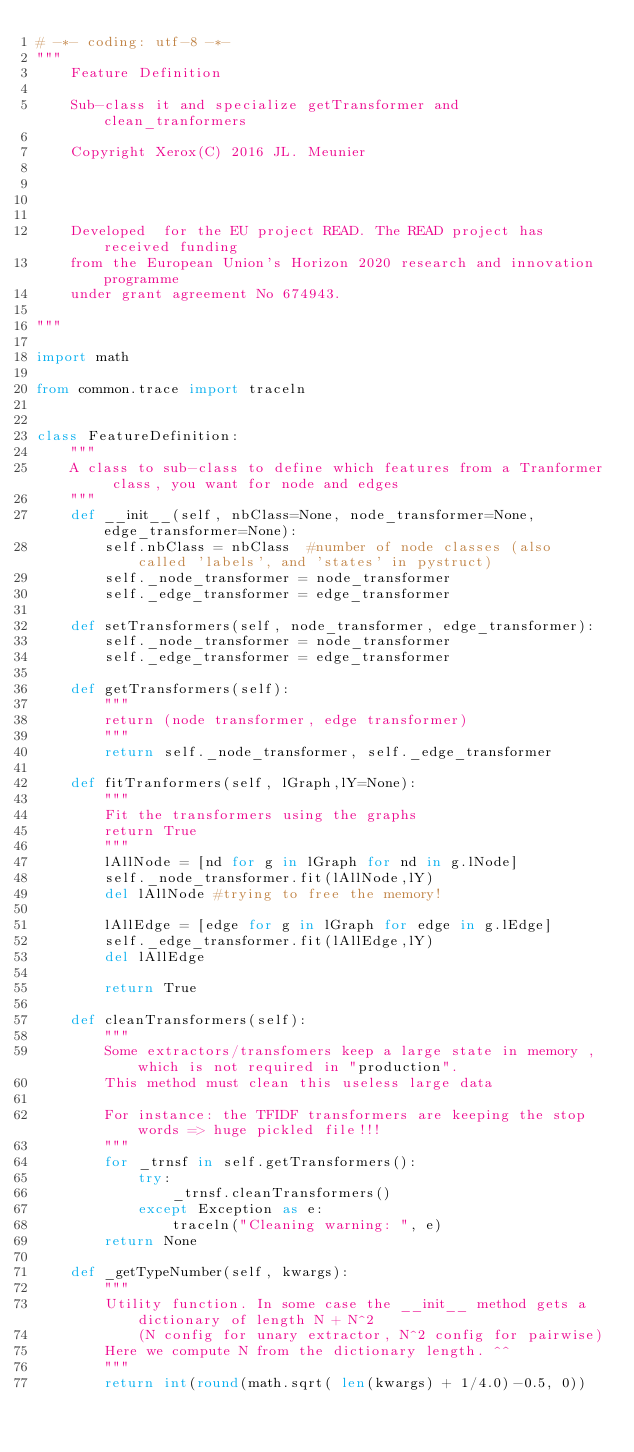<code> <loc_0><loc_0><loc_500><loc_500><_Python_># -*- coding: utf-8 -*-
"""
    Feature Definition
    
    Sub-class it and specialize getTransformer and clean_tranformers
    
    Copyright Xerox(C) 2016 JL. Meunier


    
    
    Developed  for the EU project READ. The READ project has received funding 
    from the European Union's Horizon 2020 research and innovation programme 
    under grant agreement No 674943.
    
"""

import math

from common.trace import traceln


class FeatureDefinition:
    """
    A class to sub-class to define which features from a Tranformer class, you want for node and edges
    """
    def __init__(self, nbClass=None, node_transformer=None, edge_transformer=None):
        self.nbClass = nbClass  #number of node classes (also called 'labels', and 'states' in pystruct)
        self._node_transformer = node_transformer
        self._edge_transformer = edge_transformer
        
    def setTransformers(self, node_transformer, edge_transformer):
        self._node_transformer = node_transformer
        self._edge_transformer = edge_transformer
        
    def getTransformers(self):
        """
        return (node transformer, edge transformer)
        """
        return self._node_transformer, self._edge_transformer
            
    def fitTranformers(self, lGraph,lY=None):
        """
        Fit the transformers using the graphs
        return True
        """
        lAllNode = [nd for g in lGraph for nd in g.lNode]
        self._node_transformer.fit(lAllNode,lY)
        del lAllNode #trying to free the memory!
        
        lAllEdge = [edge for g in lGraph for edge in g.lEdge]
        self._edge_transformer.fit(lAllEdge,lY)
        del lAllEdge
        
        return True

    def cleanTransformers(self):
        """
        Some extractors/transfomers keep a large state in memory , which is not required in "production".
        This method must clean this useless large data
        
        For instance: the TFIDF transformers are keeping the stop words => huge pickled file!!!
        """
        for _trnsf in self.getTransformers():
            try: 
                _trnsf.cleanTransformers()
            except Exception as e:
                traceln("Cleaning warning: ", e) 
        return None

    def _getTypeNumber(self, kwargs):
        """
        Utility function. In some case the __init__ method gets a dictionary of length N + N^2
            (N config for unary extractor, N^2 config for pairwise)
        Here we compute N from the dictionary length. ^^
        """
        return int(round(math.sqrt( len(kwargs) + 1/4.0)-0.5, 0))
    
</code> 